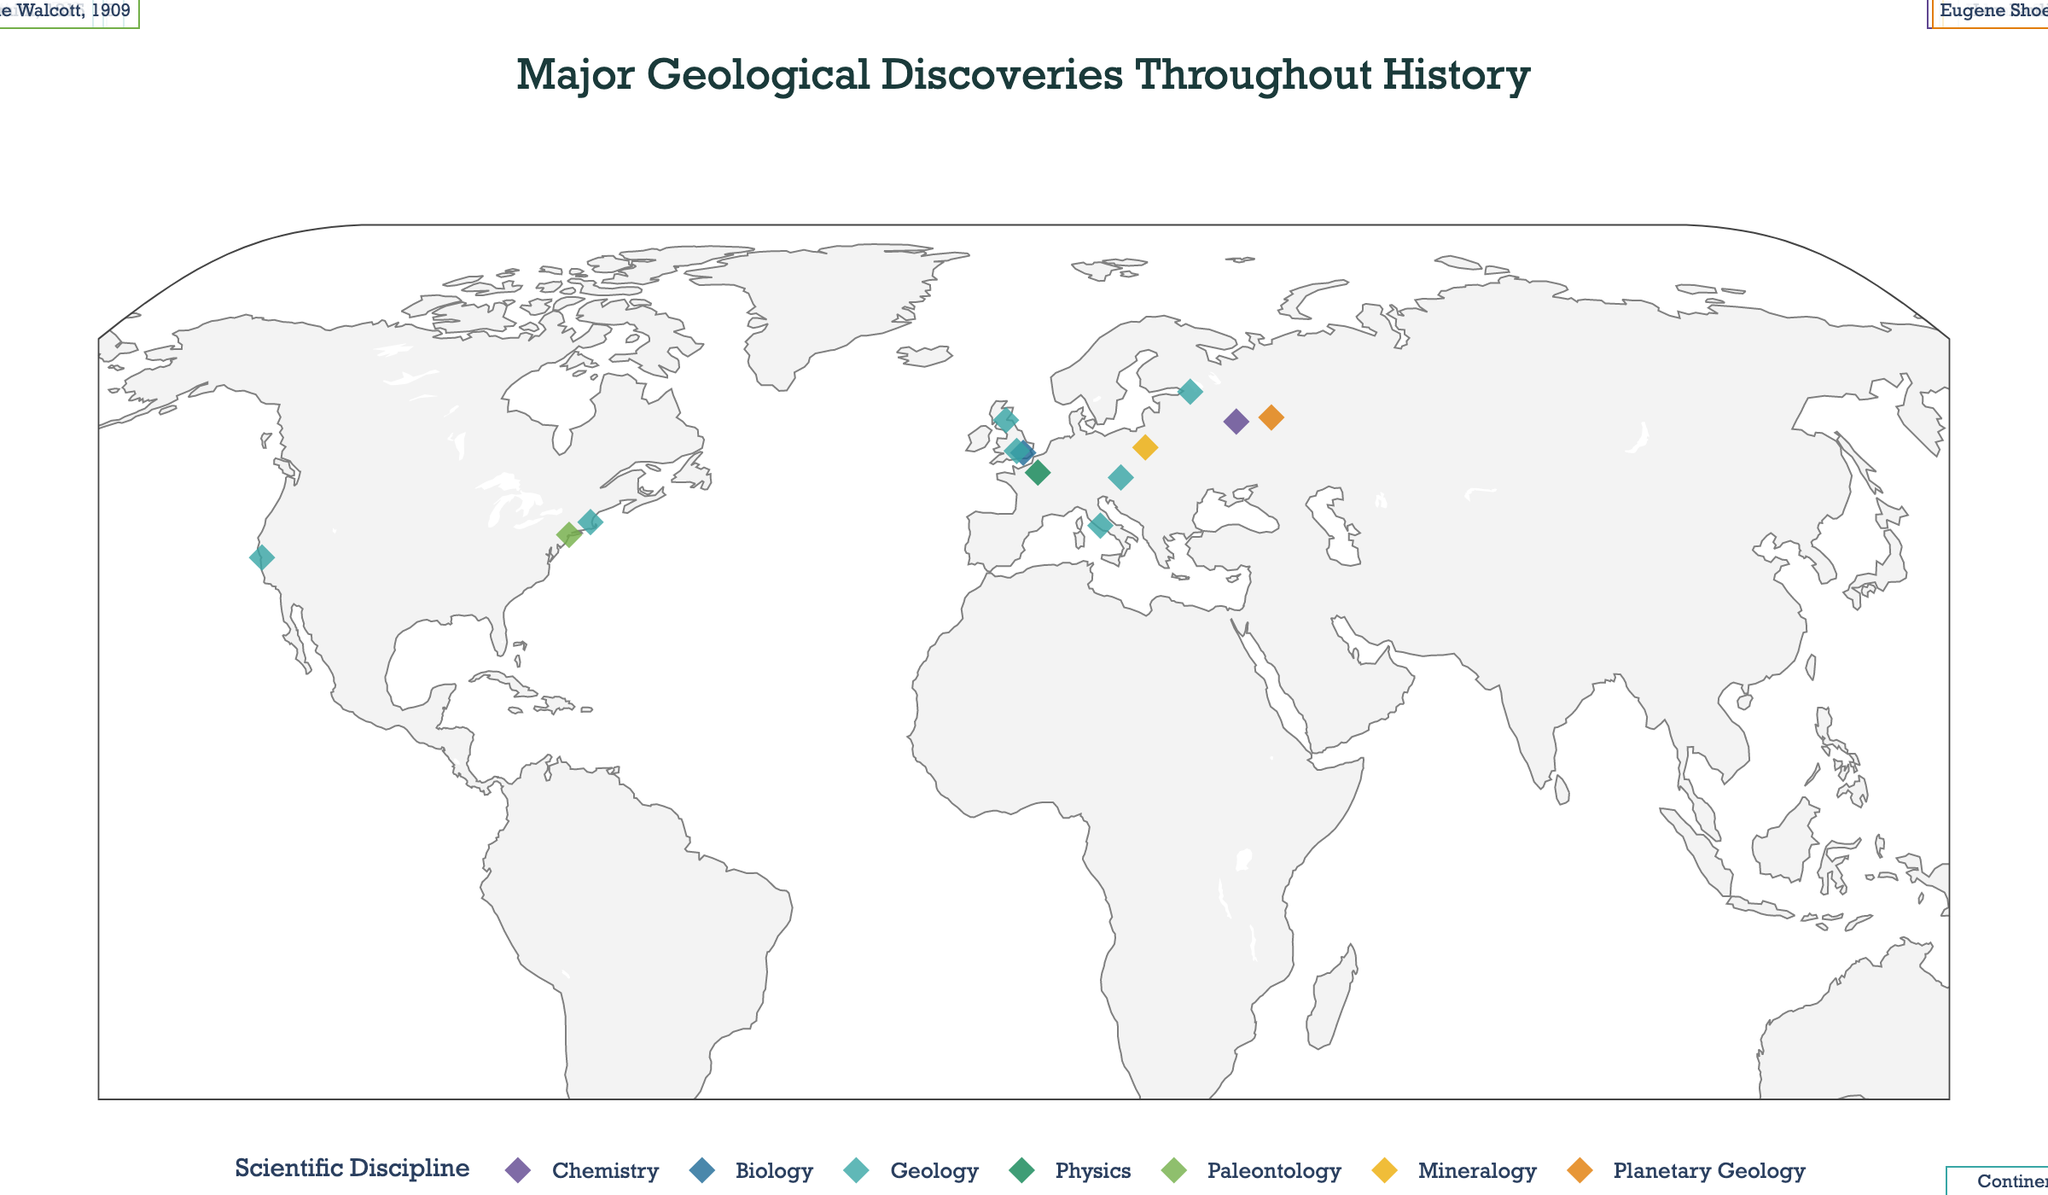What's the title of the figure? The title is displayed prominently at the top of the figure in large font. By reading it, we can determine the title.
Answer: Major Geological Discoveries Throughout History What scientific disciplines are color-coded on the map? The map uses a variety of colors to represent different scientific disciplines. By checking the legend on the map, you can list these disciplines.
Answer: Chemistry, Biology, Geology, Physics, Paleontology, Mineralogy, Planetary Geology Which discovery is marked closest to the center of the figure? The figure's center corresponds approximately to the Equator and Prime Meridian. Identify the discovery located near these coordinates on the map.
Answer: Continental Drift How many discoveries are marked in Europe? Count the data points within the European geographical boundaries on the map.
Answer: 7 Which discovery happened in the year 1869? By examining the hover info or annotations on the data points, find the one that lists the year 1869 in the text.
Answer: Periodic Table of Elements Which scientific discipline has the most discoveries on the map? Look at the distribution of colors and count the number of data points associated with each discipline to determine which has the highest count.
Answer: Geology Compare the locations of the discoveries in Geology and Chemistry. Which discipline's discoveries are more geographically spread out? By observing the geographical distribution of the data points colored for Geology and Chemistry, assess which discipline's discoveries are spread across a larger area.
Answer: Geology Among the discoveries related to Geology, which one occurred first? Check the years listed in the annotations or the hover info for the discoveries in Geology, then identify the oldest year.
Answer: Geological Time Scale How many discoveries were made before the 20th century? By examining the hover info or annotations, count all data points that list years before 1900.
Answer: 6 